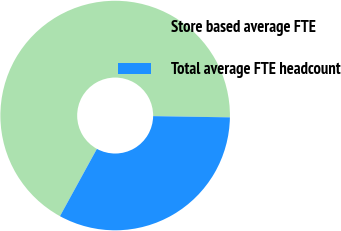<chart> <loc_0><loc_0><loc_500><loc_500><pie_chart><fcel>Store based average FTE<fcel>Total average FTE headcount<nl><fcel>67.27%<fcel>32.73%<nl></chart> 